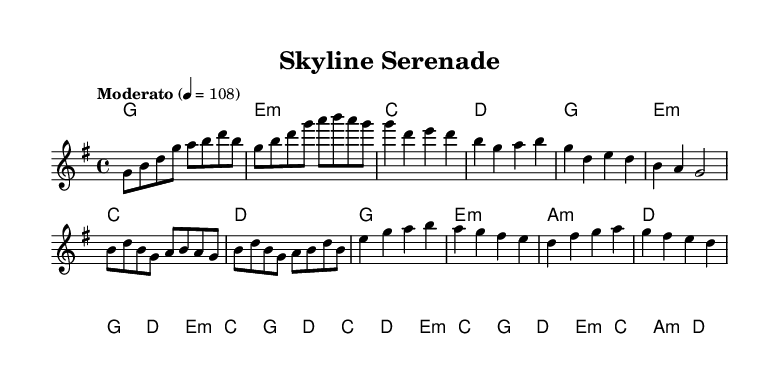What is the key signature of this music? The key signature is G major, which has one sharp (F#).
Answer: G major What is the time signature of this music? The time signature is 4/4, indicating four beats per measure.
Answer: 4/4 What is the tempo marking for this piece? The tempo marking is "Moderato," which typically indicates a moderately paced performance.
Answer: Moderato How many measures are there in the melody? The melody consists of 10 measures, as counted from the provided notation.
Answer: 10 Which chords are used in the chorus section? The chorus section uses the chords G, D, E minor, and C, as indicated by the chord symbols above the staff.
Answer: G, D, E minor, C Is there a bridge in this piece, and if so, how many measures does it have? Yes, there is a bridge section, and it contains 8 measures based on the structure seen in the sheet music.
Answer: Yes, 8 measures What style of music does this piece represent? This piece represents a fusion music style, blending traditional Indian instruments with modern pop elements, as suggested by the overall composition and instrumentation.
Answer: Fusion music 